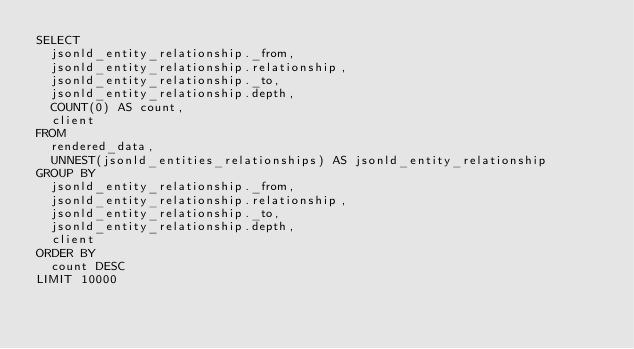<code> <loc_0><loc_0><loc_500><loc_500><_SQL_>SELECT
  jsonld_entity_relationship._from,
  jsonld_entity_relationship.relationship,
  jsonld_entity_relationship._to,
  jsonld_entity_relationship.depth,
  COUNT(0) AS count,
  client
FROM
  rendered_data,
  UNNEST(jsonld_entities_relationships) AS jsonld_entity_relationship
GROUP BY
  jsonld_entity_relationship._from,
  jsonld_entity_relationship.relationship,
  jsonld_entity_relationship._to,
  jsonld_entity_relationship.depth,
  client
ORDER BY
  count DESC
LIMIT 10000
</code> 